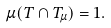<formula> <loc_0><loc_0><loc_500><loc_500>\mu ( T \cap T _ { \mu } ) = 1 .</formula> 